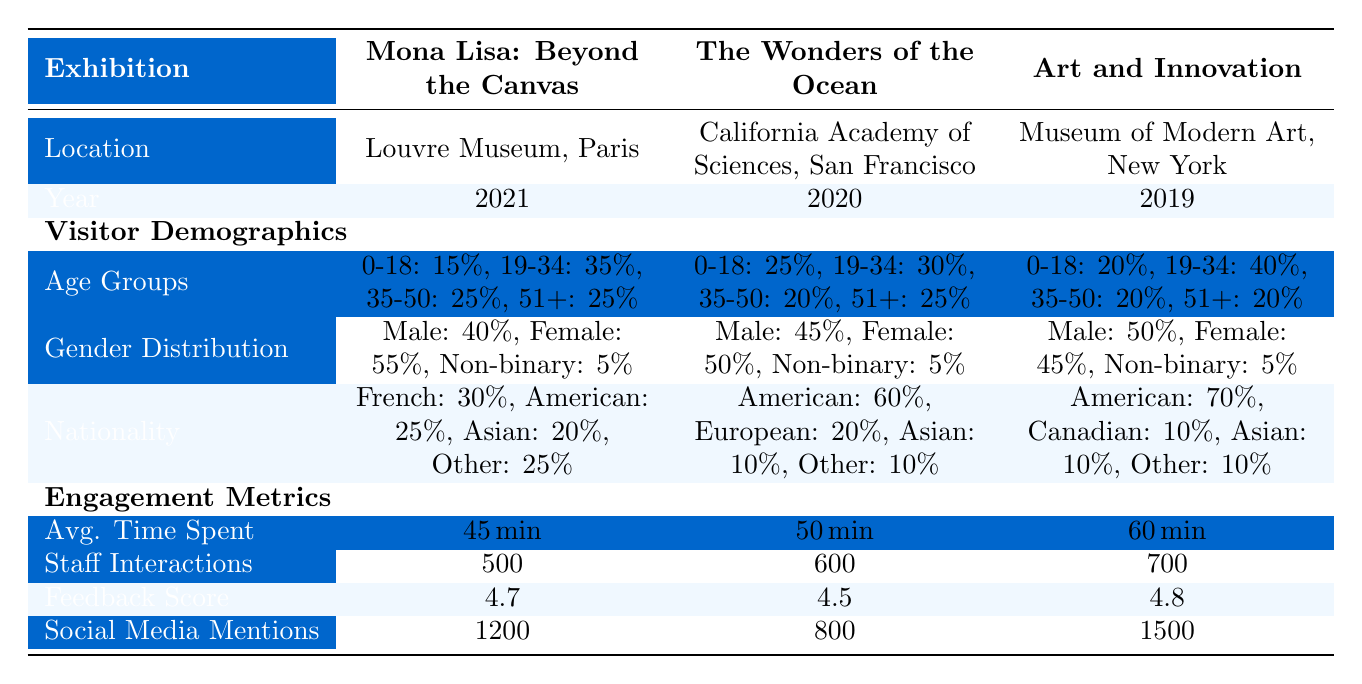What is the average time spent by visitors at the "Art and Innovation" exhibition? The table shows that visitors spent 60 minutes on average at the "Art and Innovation" exhibition, which is the specific engagement metric provided for that exhibit.
Answer: 60 minutes Which exhibition had the highest social media mentions? By comparing the social media mentions for each exhibition, "Art and Innovation" shows 1500 mentions, which is the highest among the three exhibits.
Answer: Art and Innovation Is the majority of visitors at the "Wonders of the Ocean" exhibition male? The gender distribution shows that 45% were male and 50% were female, meaning the majority of visitors were not male.
Answer: No What is the total percentage of visitors aged 0-18 across all three exhibitions? The percentages of visitors aged 0-18 are: 15% for "Mona Lisa: Beyond the Canvas," 25% for "The Wonders of the Ocean," and 20% for "Art and Innovation." Adding these gives a total of 15 + 25 + 20 = 60%.
Answer: 60% Which exhibition had the lowest average feedback score? By looking at the feedback scores, "Wonders of the Ocean" has a score of 4.5, which is lower than "Mona Lisa: Beyond the Canvas" with 4.7 and "Art and Innovation" with 4.8.
Answer: The Wonders of the Ocean What is the ratio of staff interactions between "Mona Lisa: Beyond the Canvas" and "Art and Innovation"? The staff interactions are 500 for "Mona Lisa: Beyond the Canvas" and 700 for "Art and Innovation." Finding the ratio involves dividing the two numbers: 500 / 700, which simplifies to 5:7.
Answer: 5:7 How many more social media mentions did "Art and Innovation" have compared to "The Wonders of the Ocean"? "Art and Innovation" had 1500 social media mentions, while "The Wonders of the Ocean" had 800. The difference is calculated by subtracting 800 from 1500, resulting in 1500 - 800 = 700.
Answer: 700 Is there a non-binary representation in the gender distribution of all three exhibitions? Each exhibition has a non-binary percentage of 5%, indicating that there is indeed representation across all exhibitions for non-binary individuals.
Answer: Yes 